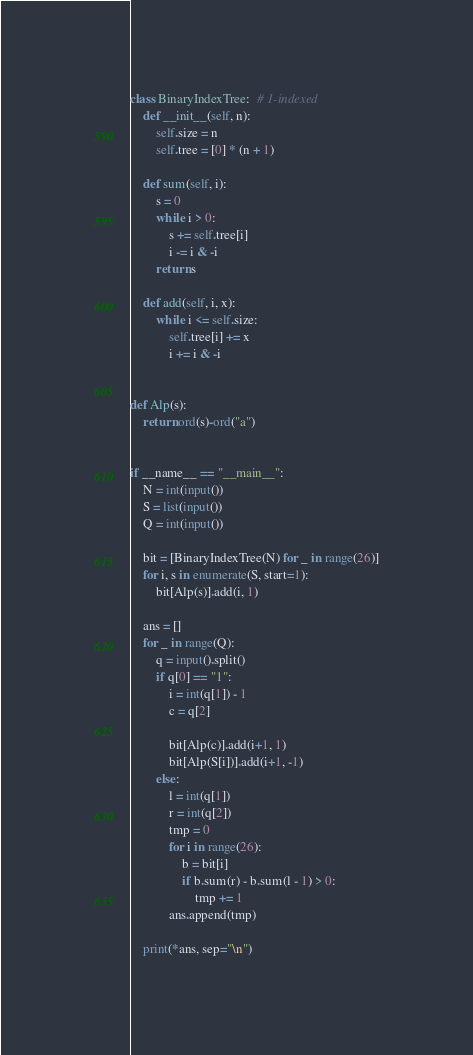Convert code to text. <code><loc_0><loc_0><loc_500><loc_500><_Python_>class BinaryIndexTree:  # 1-indexed
    def __init__(self, n):
        self.size = n
        self.tree = [0] * (n + 1)

    def sum(self, i):
        s = 0
        while i > 0:
            s += self.tree[i]
            i -= i & -i
        return s

    def add(self, i, x):
        while i <= self.size:
            self.tree[i] += x
            i += i & -i


def Alp(s):
    return ord(s)-ord("a")


if __name__ == "__main__":
    N = int(input())
    S = list(input())
    Q = int(input())

    bit = [BinaryIndexTree(N) for _ in range(26)]
    for i, s in enumerate(S, start=1):
        bit[Alp(s)].add(i, 1)

    ans = []
    for _ in range(Q):
        q = input().split()
        if q[0] == "1":
            i = int(q[1]) - 1
            c = q[2]

            bit[Alp(c)].add(i+1, 1)
            bit[Alp(S[i])].add(i+1, -1)
        else:
            l = int(q[1])
            r = int(q[2])
            tmp = 0
            for i in range(26):
                b = bit[i]
                if b.sum(r) - b.sum(l - 1) > 0:
                    tmp += 1
            ans.append(tmp)

    print(*ans, sep="\n")
</code> 